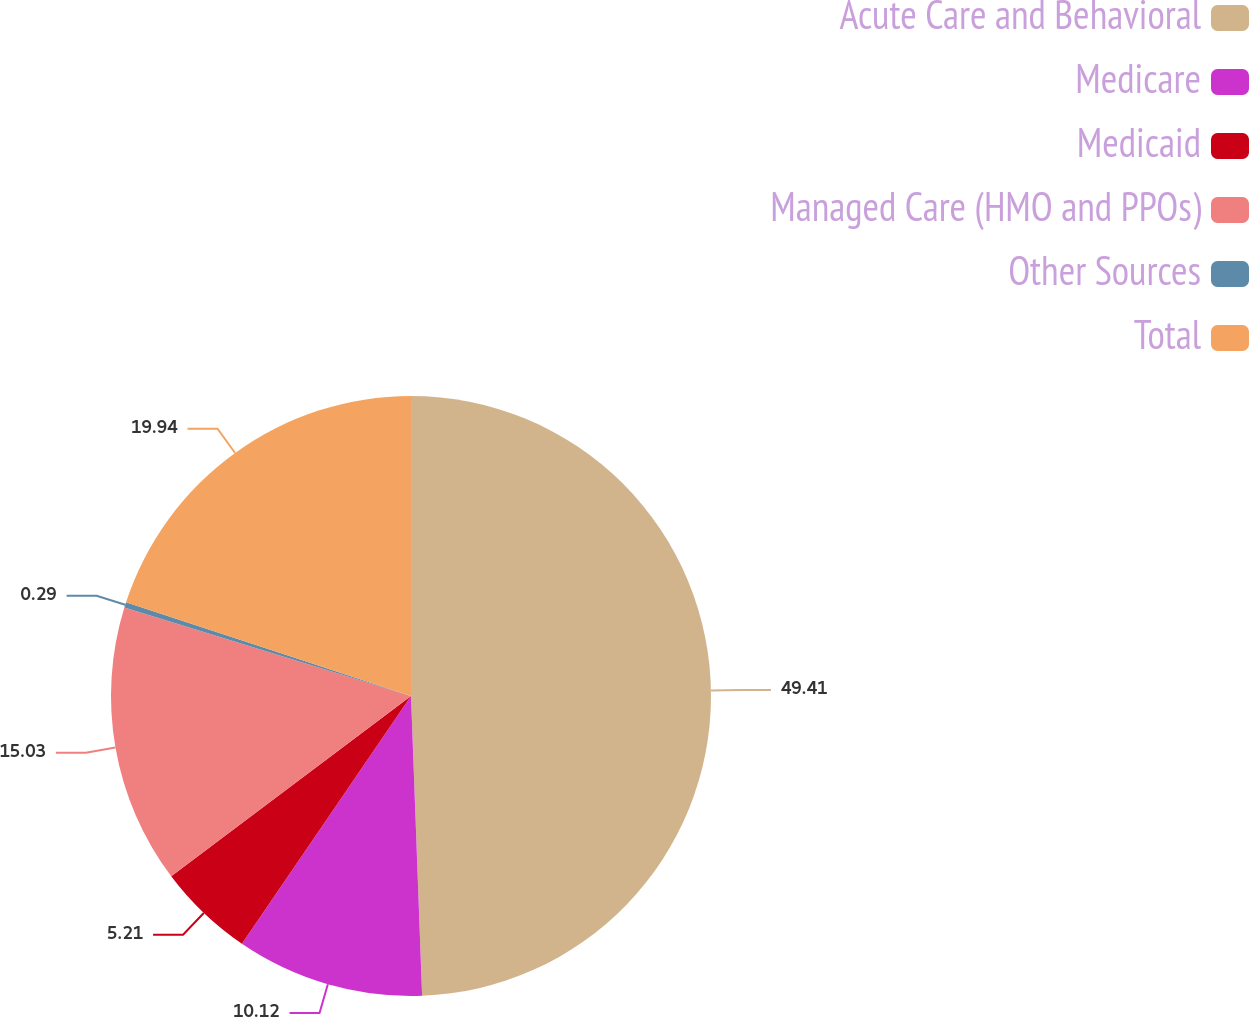<chart> <loc_0><loc_0><loc_500><loc_500><pie_chart><fcel>Acute Care and Behavioral<fcel>Medicare<fcel>Medicaid<fcel>Managed Care (HMO and PPOs)<fcel>Other Sources<fcel>Total<nl><fcel>49.41%<fcel>10.12%<fcel>5.21%<fcel>15.03%<fcel>0.29%<fcel>19.94%<nl></chart> 